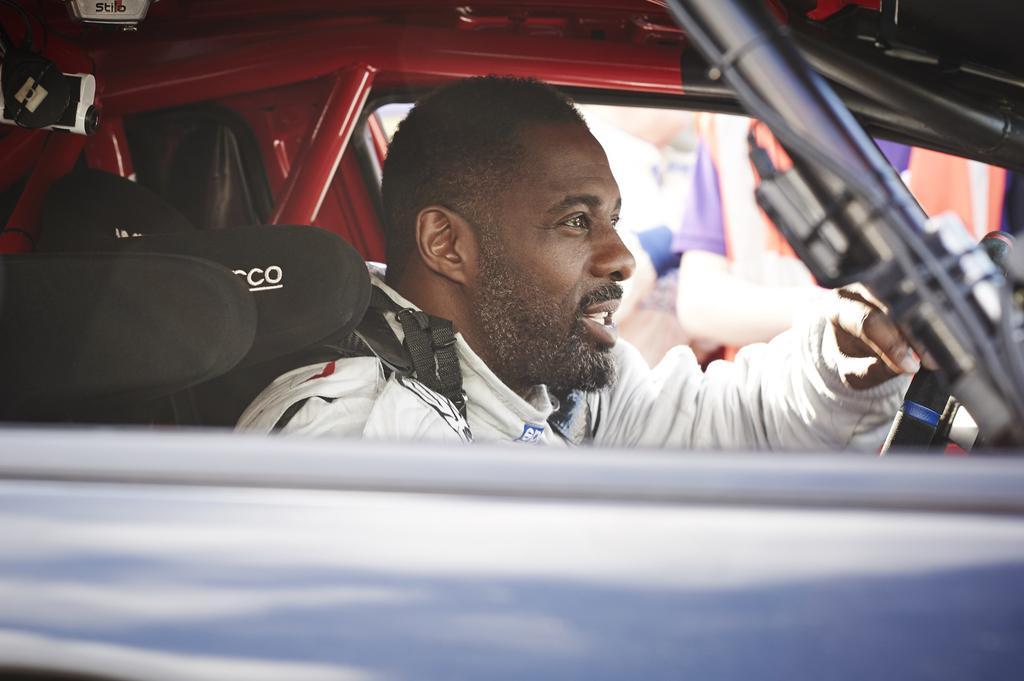Can you describe this image briefly? The person wearing white jacket is sitting in a car and holding steering. 